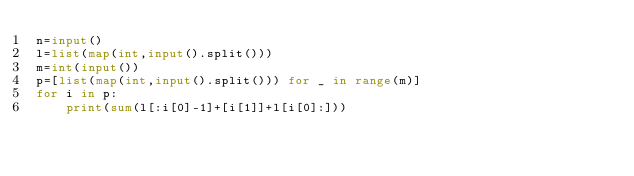<code> <loc_0><loc_0><loc_500><loc_500><_Python_>n=input()
l=list(map(int,input().split()))
m=int(input())
p=[list(map(int,input().split())) for _ in range(m)]
for i in p:
    print(sum(l[:i[0]-1]+[i[1]]+l[i[0]:]))</code> 